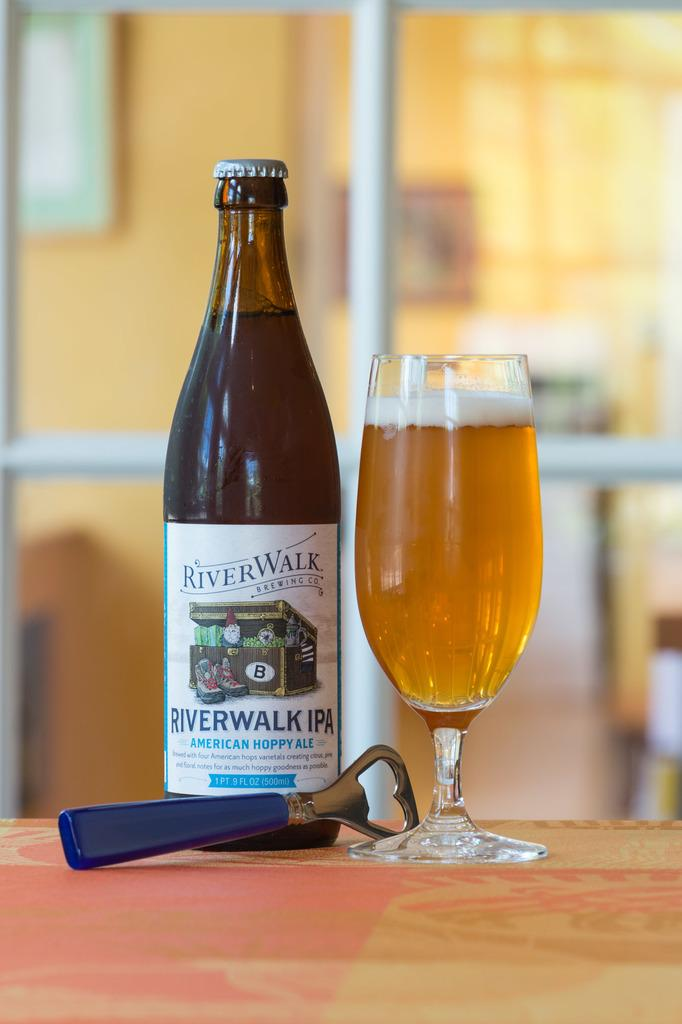<image>
Share a concise interpretation of the image provided. A bottle of River Walk placed next to a glass of light golden beer. 